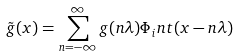<formula> <loc_0><loc_0><loc_500><loc_500>\tilde { g } ( x ) = \sum _ { n = - \infty } ^ { \infty } g ( n \lambda ) \Phi _ { i } n t ( x - n \lambda )</formula> 